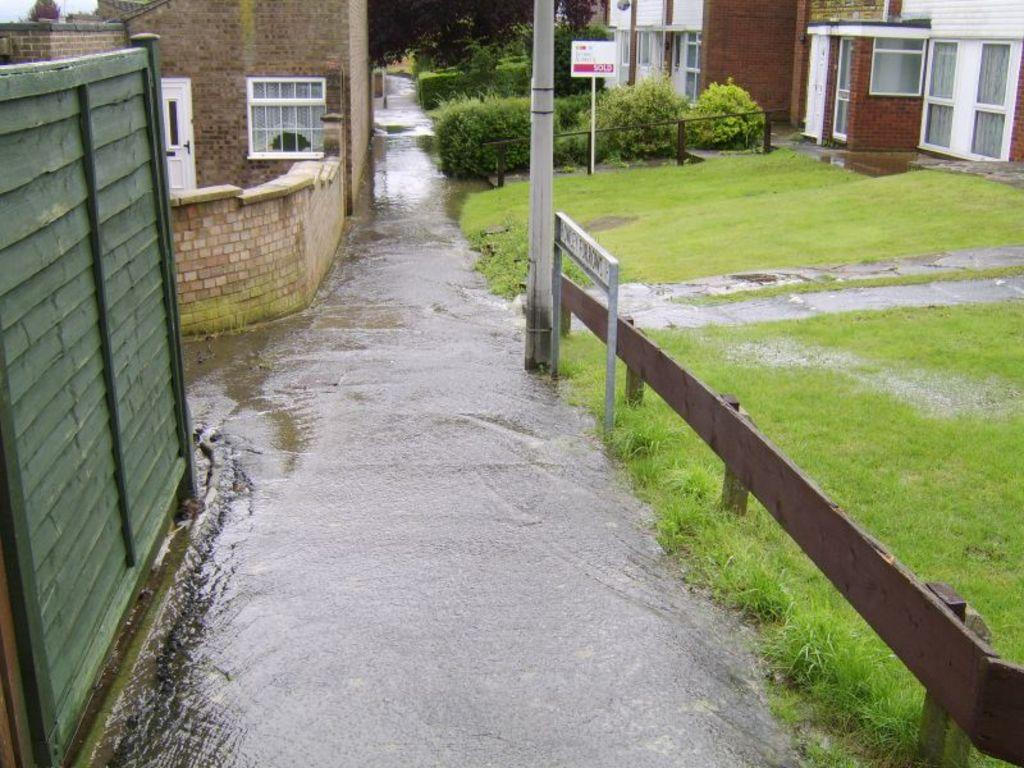What type of structures can be seen in the image? There are houses in the image. What features are present on the houses? There are doors and windows in the image. What type of vegetation is visible in the image? There are trees, plants, and grass in the image. What type of signage is present in the image? There are boards with text in the image. What type of barriers are present in the image? There is fencing in the image. What type of walls are present in the image? There is a wooden wall and a brick wall in the image. Can you tell me how many times the queen kicked the ball in the image? There is no queen or ball present in the image, so this action cannot be observed. 